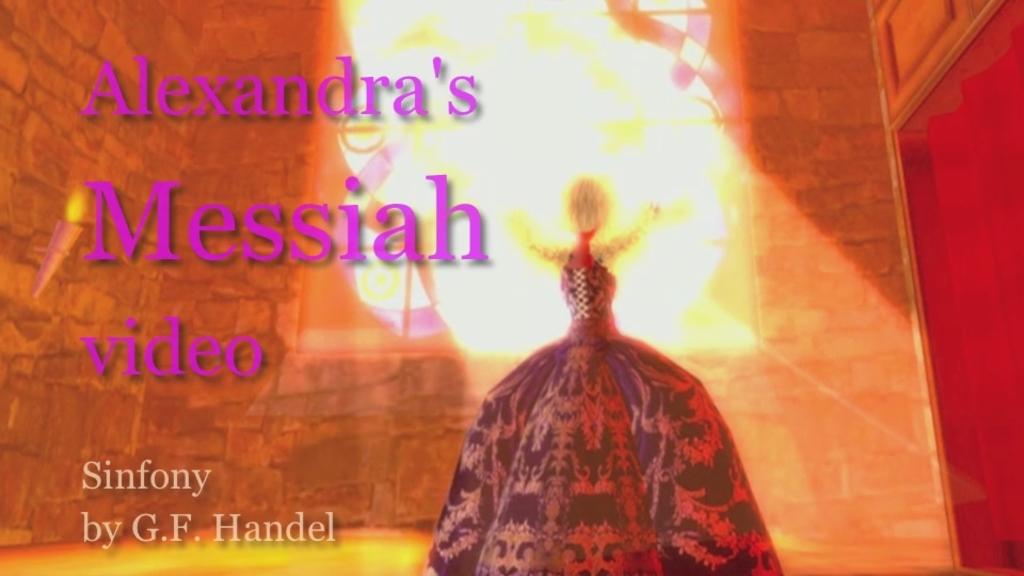What is the title of the video?
Give a very brief answer. Alexandra's messiah video. 